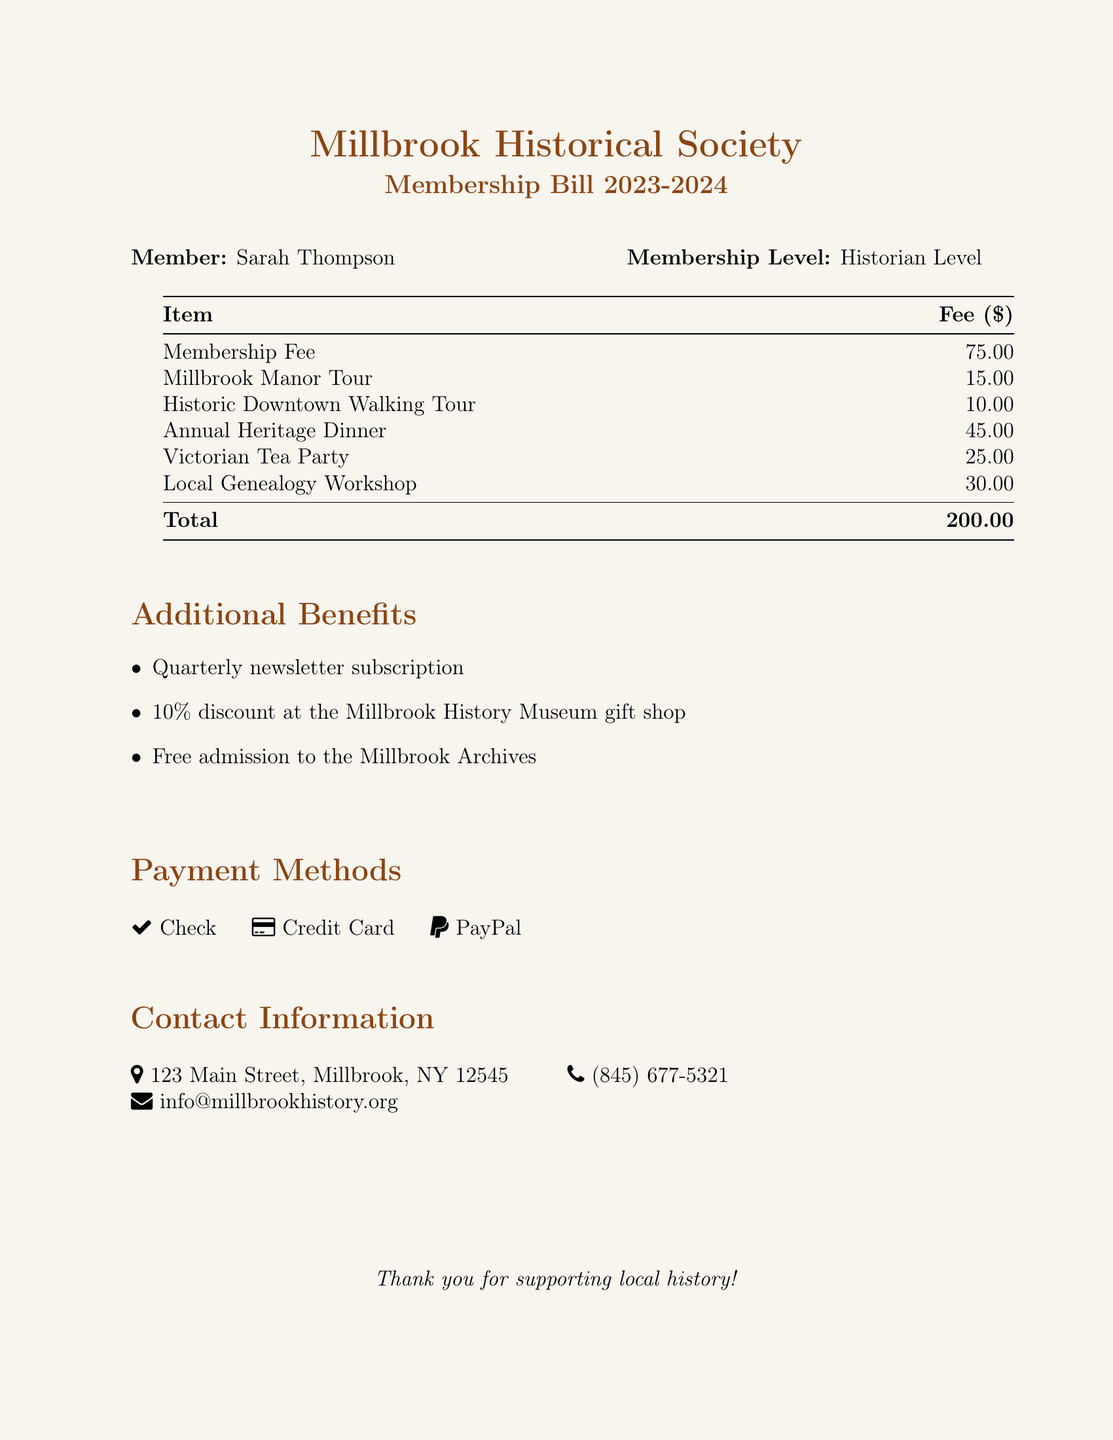what is the total fee? The total fee is the sum of all listed fees in the document, which is $75.00 + $15.00 + $10.00 + $45.00 + $25.00 + $30.00 = $200.00.
Answer: $200.00 who is the member listed on the bill? The bill mentions the member's name at the top, which is Sarah Thompson.
Answer: Sarah Thompson what is the fee for the Annual Heritage Dinner? The fee for the Annual Heritage Dinner is specified in the itemized list in the document.
Answer: $45.00 how many community events are listed? The document lists all events under fees, which includes a total of five events.
Answer: 5 what percentage discount do members receive at the gift shop? The document indicates the discount provided at the gift shop as mentioned in the additional benefits section.
Answer: 10% what payment methods are accepted? The document lists the payment methods in a section dedicated to that information.
Answer: Check, Credit Card, PayPal what is the address of the Millbrook Historical Society? The address is presented in the contact information section of the document.
Answer: 123 Main Street, Millbrook, NY 12545 what membership level does Sarah Thompson hold? The membership level is specified next to her name in the document, indicating her tier.
Answer: Historian Level 